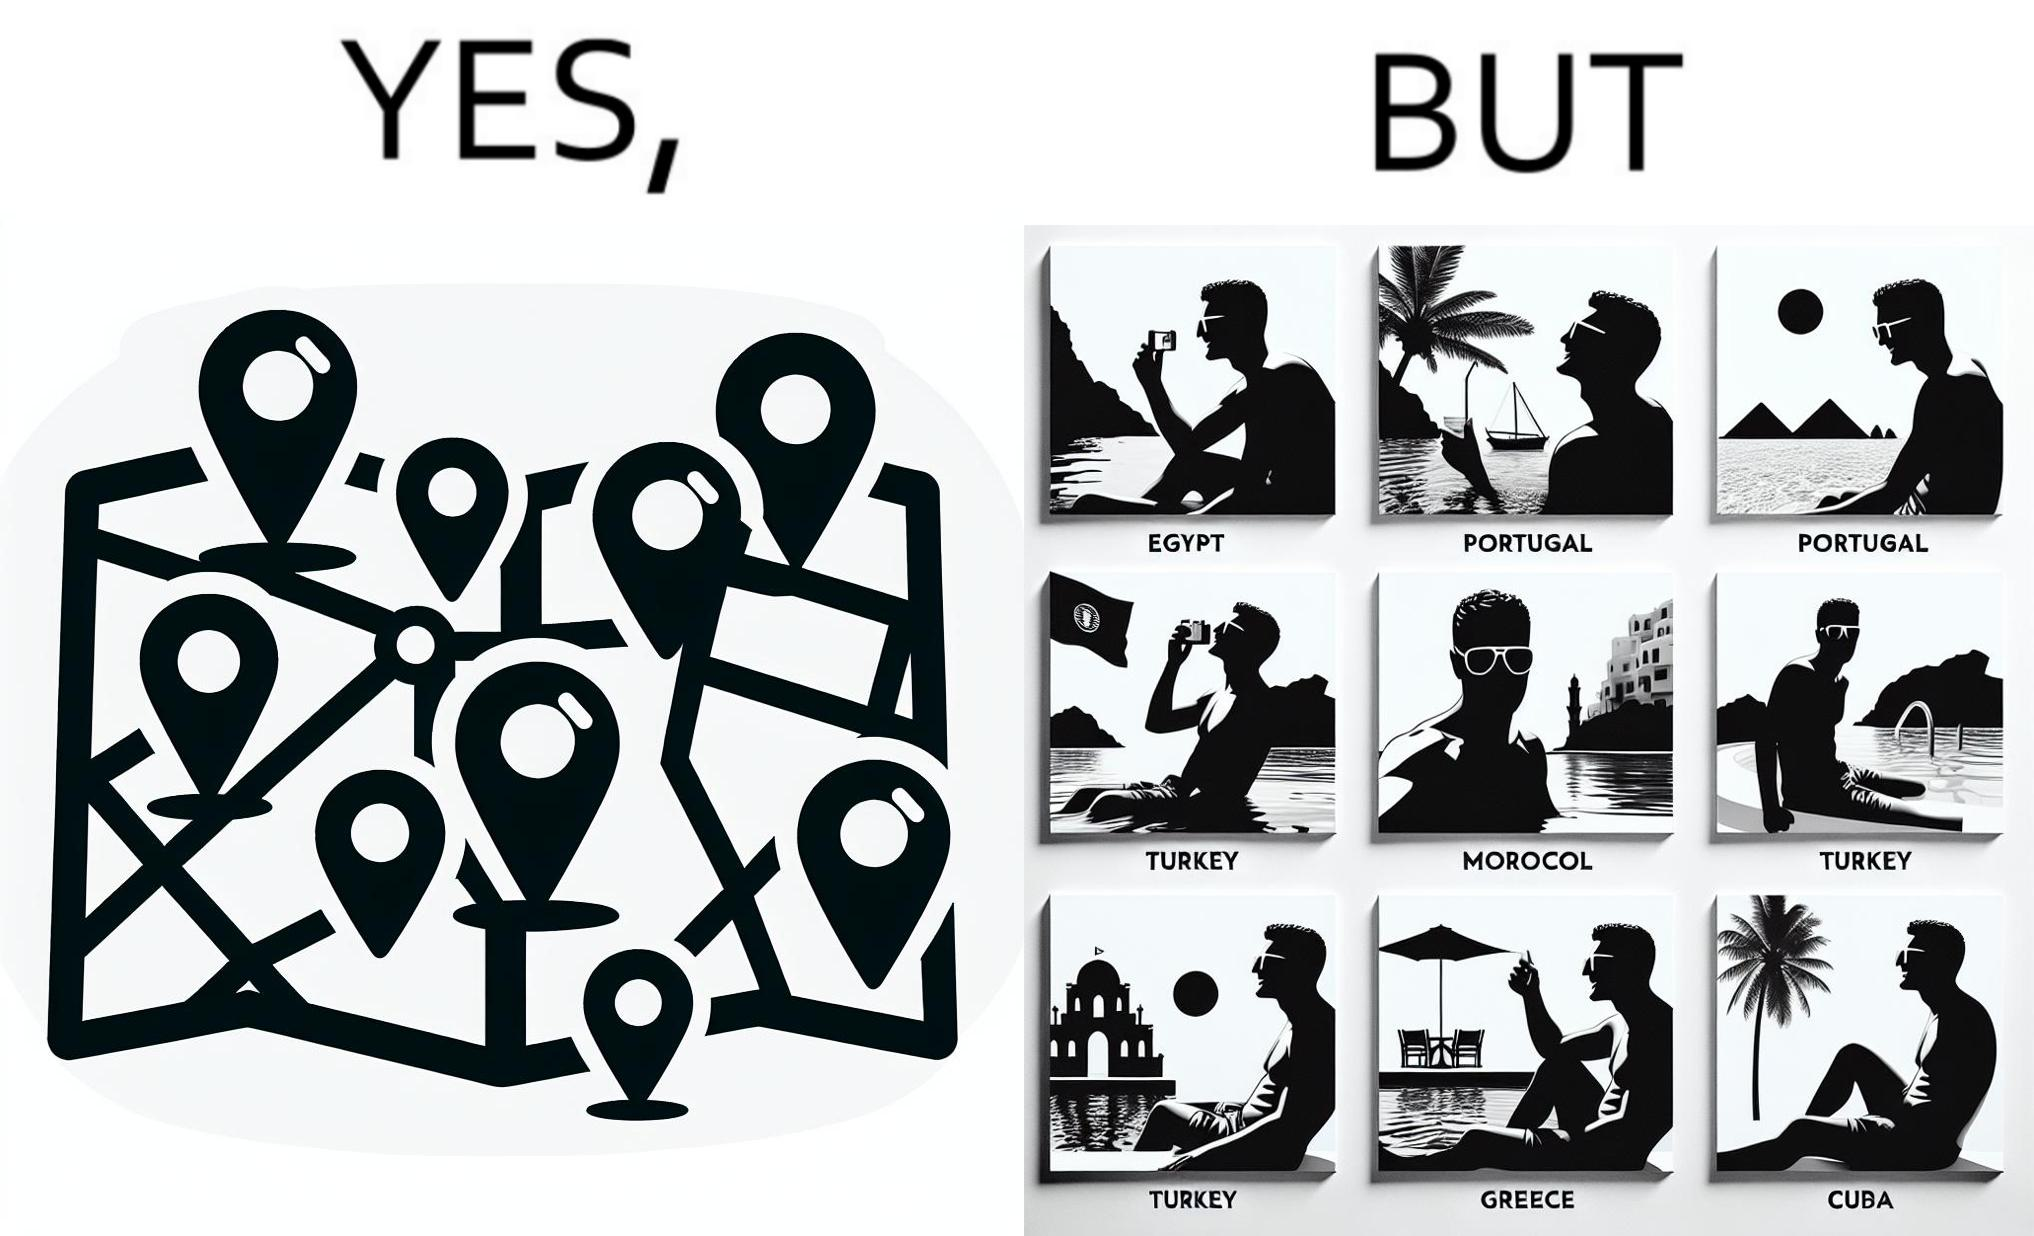Is there satirical content in this image? Yes, this image is satirical. 